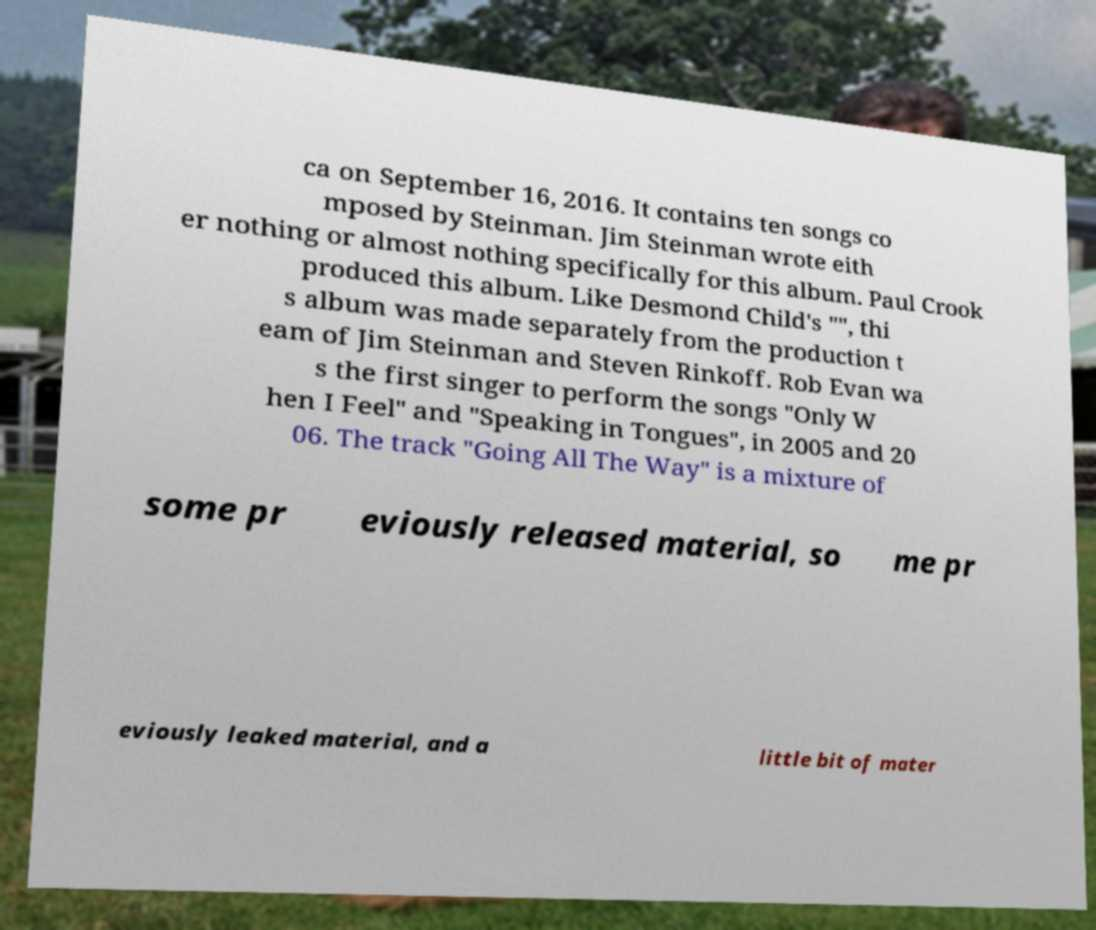Could you assist in decoding the text presented in this image and type it out clearly? ca on September 16, 2016. It contains ten songs co mposed by Steinman. Jim Steinman wrote eith er nothing or almost nothing specifically for this album. Paul Crook produced this album. Like Desmond Child's "", thi s album was made separately from the production t eam of Jim Steinman and Steven Rinkoff. Rob Evan wa s the first singer to perform the songs "Only W hen I Feel" and "Speaking in Tongues", in 2005 and 20 06. The track "Going All The Way" is a mixture of some pr eviously released material, so me pr eviously leaked material, and a little bit of mater 